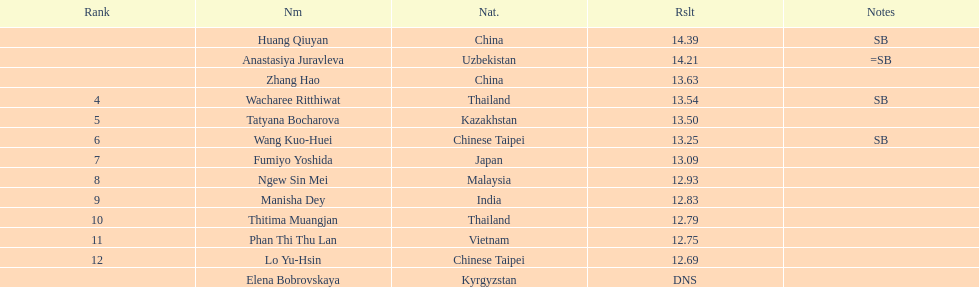How many people were ranked? 12. 